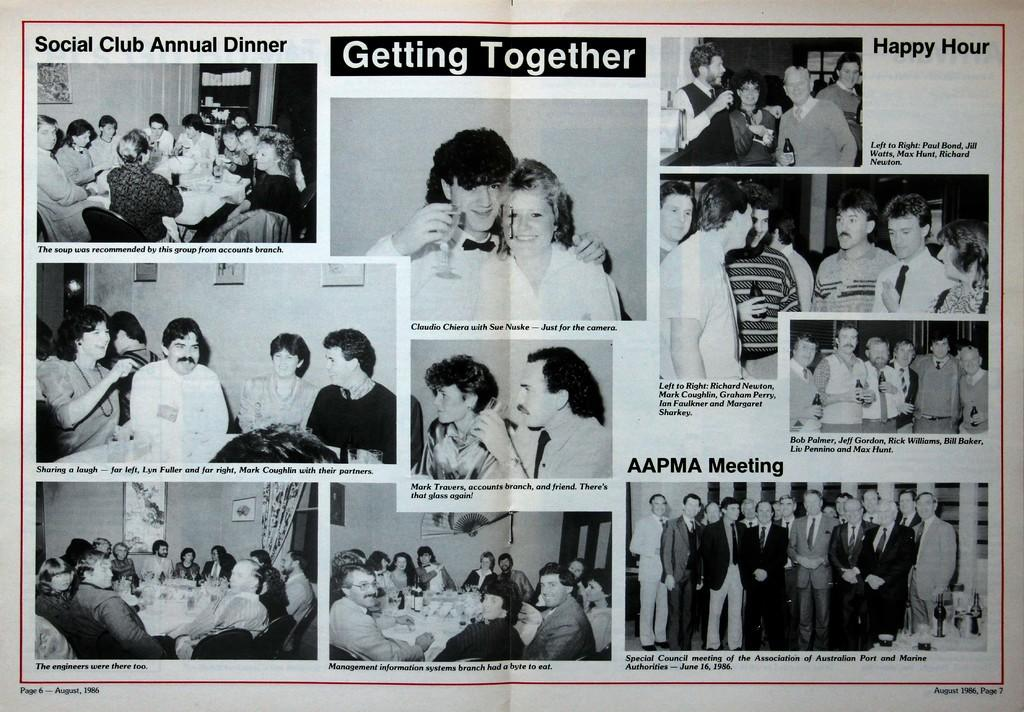What is the main object in the image? There is a paper in the image. What are the people in the image doing with the paper? The people are standing and sitting on the paper. What else can be seen in the hands of the people in the image? The people are holding glasses. Can you tell me how many crows are sitting on the paper in the image? There are no crows present in the image; it features people standing and sitting on a paper and holding glasses. What type of cheese is being served on the paper in the image? There is no cheese present in the image. 